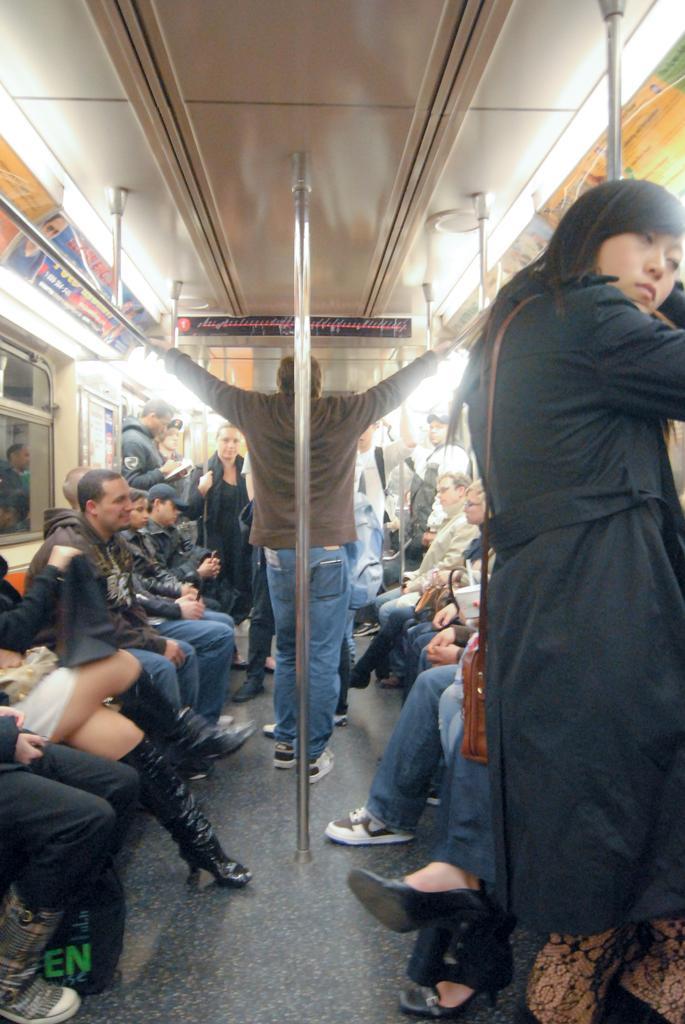Please provide a concise description of this image. In the image we can see the internal structure of a vehicle. In it we can see there are people sitting and some of them are standing, they are wearing clothes and some of them are wearing shoes and carrying bags. Here we can see the floor, poles, lights and the window. 